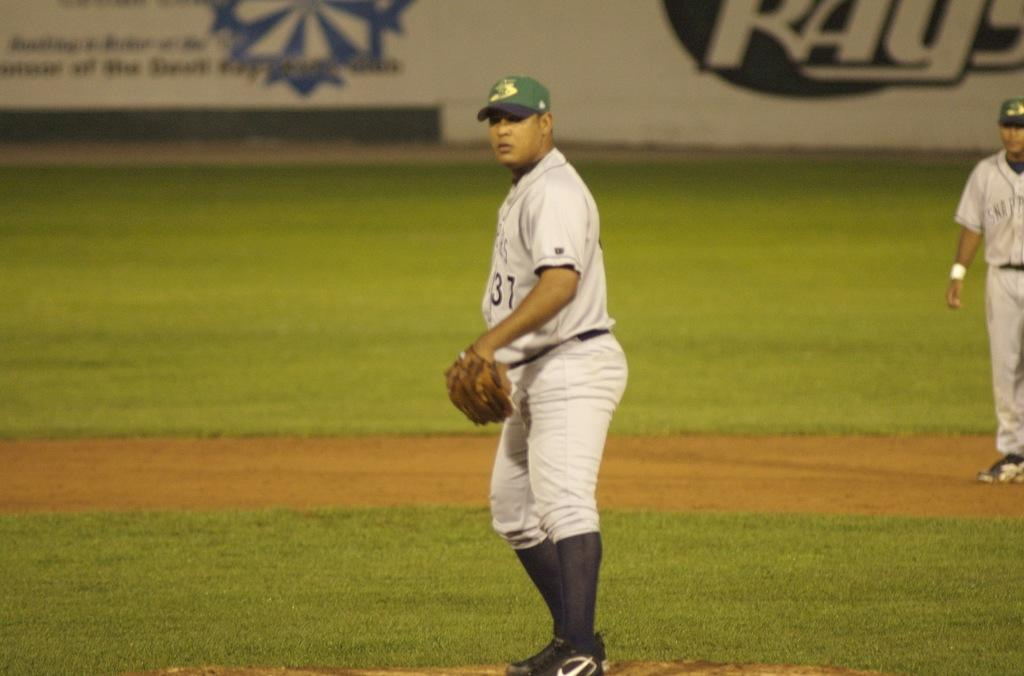<image>
Create a compact narrative representing the image presented. A baseball player has "31" text on his shirt. 